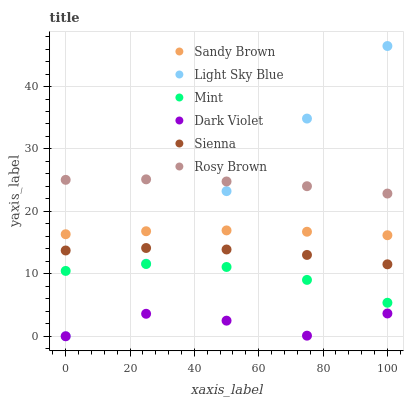Does Dark Violet have the minimum area under the curve?
Answer yes or no. Yes. Does Rosy Brown have the maximum area under the curve?
Answer yes or no. Yes. Does Rosy Brown have the minimum area under the curve?
Answer yes or no. No. Does Dark Violet have the maximum area under the curve?
Answer yes or no. No. Is Light Sky Blue the smoothest?
Answer yes or no. Yes. Is Dark Violet the roughest?
Answer yes or no. Yes. Is Rosy Brown the smoothest?
Answer yes or no. No. Is Rosy Brown the roughest?
Answer yes or no. No. Does Dark Violet have the lowest value?
Answer yes or no. Yes. Does Rosy Brown have the lowest value?
Answer yes or no. No. Does Light Sky Blue have the highest value?
Answer yes or no. Yes. Does Rosy Brown have the highest value?
Answer yes or no. No. Is Sienna less than Rosy Brown?
Answer yes or no. Yes. Is Rosy Brown greater than Dark Violet?
Answer yes or no. Yes. Does Sienna intersect Light Sky Blue?
Answer yes or no. Yes. Is Sienna less than Light Sky Blue?
Answer yes or no. No. Is Sienna greater than Light Sky Blue?
Answer yes or no. No. Does Sienna intersect Rosy Brown?
Answer yes or no. No. 